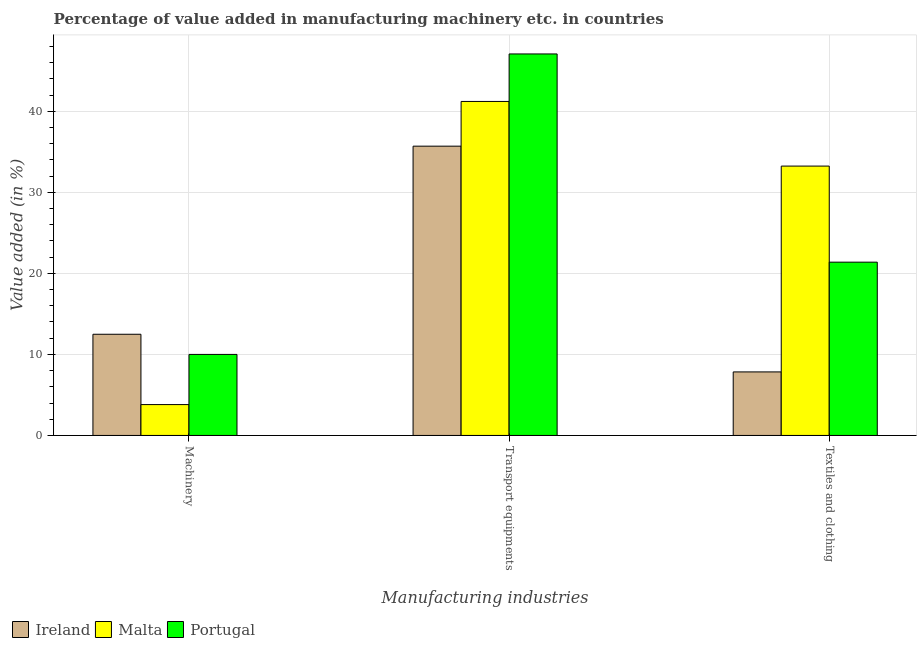How many different coloured bars are there?
Provide a succinct answer. 3. How many groups of bars are there?
Provide a short and direct response. 3. Are the number of bars per tick equal to the number of legend labels?
Offer a very short reply. Yes. What is the label of the 1st group of bars from the left?
Your response must be concise. Machinery. What is the value added in manufacturing machinery in Ireland?
Your answer should be very brief. 12.48. Across all countries, what is the maximum value added in manufacturing textile and clothing?
Give a very brief answer. 33.23. Across all countries, what is the minimum value added in manufacturing machinery?
Your response must be concise. 3.81. In which country was the value added in manufacturing transport equipments minimum?
Your answer should be compact. Ireland. What is the total value added in manufacturing machinery in the graph?
Your answer should be compact. 26.29. What is the difference between the value added in manufacturing transport equipments in Malta and that in Portugal?
Keep it short and to the point. -5.86. What is the difference between the value added in manufacturing transport equipments in Malta and the value added in manufacturing textile and clothing in Ireland?
Ensure brevity in your answer.  33.37. What is the average value added in manufacturing textile and clothing per country?
Your answer should be very brief. 20.82. What is the difference between the value added in manufacturing machinery and value added in manufacturing transport equipments in Ireland?
Provide a short and direct response. -23.21. What is the ratio of the value added in manufacturing textile and clothing in Malta to that in Ireland?
Provide a short and direct response. 4.24. Is the difference between the value added in manufacturing machinery in Portugal and Malta greater than the difference between the value added in manufacturing transport equipments in Portugal and Malta?
Your answer should be very brief. Yes. What is the difference between the highest and the second highest value added in manufacturing textile and clothing?
Offer a terse response. 11.85. What is the difference between the highest and the lowest value added in manufacturing transport equipments?
Offer a very short reply. 11.38. In how many countries, is the value added in manufacturing machinery greater than the average value added in manufacturing machinery taken over all countries?
Your response must be concise. 2. Is the sum of the value added in manufacturing transport equipments in Ireland and Malta greater than the maximum value added in manufacturing machinery across all countries?
Your answer should be compact. Yes. What does the 3rd bar from the left in Textiles and clothing represents?
Offer a terse response. Portugal. What does the 3rd bar from the right in Machinery represents?
Ensure brevity in your answer.  Ireland. Is it the case that in every country, the sum of the value added in manufacturing machinery and value added in manufacturing transport equipments is greater than the value added in manufacturing textile and clothing?
Your answer should be compact. Yes. How many bars are there?
Make the answer very short. 9. How many legend labels are there?
Offer a terse response. 3. How are the legend labels stacked?
Keep it short and to the point. Horizontal. What is the title of the graph?
Your response must be concise. Percentage of value added in manufacturing machinery etc. in countries. Does "Guinea" appear as one of the legend labels in the graph?
Your answer should be very brief. No. What is the label or title of the X-axis?
Your response must be concise. Manufacturing industries. What is the label or title of the Y-axis?
Make the answer very short. Value added (in %). What is the Value added (in %) of Ireland in Machinery?
Provide a succinct answer. 12.48. What is the Value added (in %) in Malta in Machinery?
Your response must be concise. 3.81. What is the Value added (in %) of Portugal in Machinery?
Give a very brief answer. 10. What is the Value added (in %) of Ireland in Transport equipments?
Your answer should be compact. 35.69. What is the Value added (in %) of Malta in Transport equipments?
Your response must be concise. 41.21. What is the Value added (in %) in Portugal in Transport equipments?
Your answer should be very brief. 47.07. What is the Value added (in %) of Ireland in Textiles and clothing?
Offer a terse response. 7.84. What is the Value added (in %) in Malta in Textiles and clothing?
Your answer should be compact. 33.23. What is the Value added (in %) in Portugal in Textiles and clothing?
Your answer should be compact. 21.38. Across all Manufacturing industries, what is the maximum Value added (in %) in Ireland?
Offer a terse response. 35.69. Across all Manufacturing industries, what is the maximum Value added (in %) of Malta?
Make the answer very short. 41.21. Across all Manufacturing industries, what is the maximum Value added (in %) of Portugal?
Provide a succinct answer. 47.07. Across all Manufacturing industries, what is the minimum Value added (in %) in Ireland?
Your answer should be very brief. 7.84. Across all Manufacturing industries, what is the minimum Value added (in %) of Malta?
Offer a very short reply. 3.81. Across all Manufacturing industries, what is the minimum Value added (in %) in Portugal?
Offer a very short reply. 10. What is the total Value added (in %) in Ireland in the graph?
Ensure brevity in your answer.  56.01. What is the total Value added (in %) in Malta in the graph?
Your answer should be very brief. 78.25. What is the total Value added (in %) in Portugal in the graph?
Your answer should be compact. 78.45. What is the difference between the Value added (in %) in Ireland in Machinery and that in Transport equipments?
Make the answer very short. -23.21. What is the difference between the Value added (in %) in Malta in Machinery and that in Transport equipments?
Your answer should be compact. -37.4. What is the difference between the Value added (in %) in Portugal in Machinery and that in Transport equipments?
Provide a short and direct response. -37.07. What is the difference between the Value added (in %) in Ireland in Machinery and that in Textiles and clothing?
Your response must be concise. 4.65. What is the difference between the Value added (in %) of Malta in Machinery and that in Textiles and clothing?
Offer a very short reply. -29.43. What is the difference between the Value added (in %) in Portugal in Machinery and that in Textiles and clothing?
Offer a terse response. -11.38. What is the difference between the Value added (in %) of Ireland in Transport equipments and that in Textiles and clothing?
Your response must be concise. 27.86. What is the difference between the Value added (in %) of Malta in Transport equipments and that in Textiles and clothing?
Make the answer very short. 7.98. What is the difference between the Value added (in %) in Portugal in Transport equipments and that in Textiles and clothing?
Keep it short and to the point. 25.69. What is the difference between the Value added (in %) of Ireland in Machinery and the Value added (in %) of Malta in Transport equipments?
Make the answer very short. -28.73. What is the difference between the Value added (in %) of Ireland in Machinery and the Value added (in %) of Portugal in Transport equipments?
Your answer should be very brief. -34.59. What is the difference between the Value added (in %) of Malta in Machinery and the Value added (in %) of Portugal in Transport equipments?
Make the answer very short. -43.26. What is the difference between the Value added (in %) in Ireland in Machinery and the Value added (in %) in Malta in Textiles and clothing?
Your response must be concise. -20.75. What is the difference between the Value added (in %) of Ireland in Machinery and the Value added (in %) of Portugal in Textiles and clothing?
Offer a very short reply. -8.9. What is the difference between the Value added (in %) of Malta in Machinery and the Value added (in %) of Portugal in Textiles and clothing?
Your answer should be very brief. -17.57. What is the difference between the Value added (in %) of Ireland in Transport equipments and the Value added (in %) of Malta in Textiles and clothing?
Keep it short and to the point. 2.46. What is the difference between the Value added (in %) in Ireland in Transport equipments and the Value added (in %) in Portugal in Textiles and clothing?
Make the answer very short. 14.31. What is the difference between the Value added (in %) in Malta in Transport equipments and the Value added (in %) in Portugal in Textiles and clothing?
Your answer should be compact. 19.83. What is the average Value added (in %) of Ireland per Manufacturing industries?
Provide a short and direct response. 18.67. What is the average Value added (in %) in Malta per Manufacturing industries?
Give a very brief answer. 26.08. What is the average Value added (in %) of Portugal per Manufacturing industries?
Provide a short and direct response. 26.15. What is the difference between the Value added (in %) in Ireland and Value added (in %) in Malta in Machinery?
Your response must be concise. 8.68. What is the difference between the Value added (in %) of Ireland and Value added (in %) of Portugal in Machinery?
Offer a very short reply. 2.49. What is the difference between the Value added (in %) of Malta and Value added (in %) of Portugal in Machinery?
Your answer should be compact. -6.19. What is the difference between the Value added (in %) of Ireland and Value added (in %) of Malta in Transport equipments?
Your response must be concise. -5.52. What is the difference between the Value added (in %) of Ireland and Value added (in %) of Portugal in Transport equipments?
Make the answer very short. -11.38. What is the difference between the Value added (in %) in Malta and Value added (in %) in Portugal in Transport equipments?
Your response must be concise. -5.86. What is the difference between the Value added (in %) in Ireland and Value added (in %) in Malta in Textiles and clothing?
Your answer should be compact. -25.4. What is the difference between the Value added (in %) of Ireland and Value added (in %) of Portugal in Textiles and clothing?
Provide a short and direct response. -13.54. What is the difference between the Value added (in %) of Malta and Value added (in %) of Portugal in Textiles and clothing?
Give a very brief answer. 11.85. What is the ratio of the Value added (in %) of Ireland in Machinery to that in Transport equipments?
Provide a succinct answer. 0.35. What is the ratio of the Value added (in %) of Malta in Machinery to that in Transport equipments?
Provide a short and direct response. 0.09. What is the ratio of the Value added (in %) of Portugal in Machinery to that in Transport equipments?
Your response must be concise. 0.21. What is the ratio of the Value added (in %) of Ireland in Machinery to that in Textiles and clothing?
Provide a succinct answer. 1.59. What is the ratio of the Value added (in %) in Malta in Machinery to that in Textiles and clothing?
Ensure brevity in your answer.  0.11. What is the ratio of the Value added (in %) of Portugal in Machinery to that in Textiles and clothing?
Offer a terse response. 0.47. What is the ratio of the Value added (in %) in Ireland in Transport equipments to that in Textiles and clothing?
Ensure brevity in your answer.  4.55. What is the ratio of the Value added (in %) of Malta in Transport equipments to that in Textiles and clothing?
Offer a very short reply. 1.24. What is the ratio of the Value added (in %) of Portugal in Transport equipments to that in Textiles and clothing?
Your answer should be compact. 2.2. What is the difference between the highest and the second highest Value added (in %) of Ireland?
Keep it short and to the point. 23.21. What is the difference between the highest and the second highest Value added (in %) in Malta?
Offer a very short reply. 7.98. What is the difference between the highest and the second highest Value added (in %) of Portugal?
Keep it short and to the point. 25.69. What is the difference between the highest and the lowest Value added (in %) in Ireland?
Offer a terse response. 27.86. What is the difference between the highest and the lowest Value added (in %) of Malta?
Provide a short and direct response. 37.4. What is the difference between the highest and the lowest Value added (in %) in Portugal?
Offer a very short reply. 37.07. 